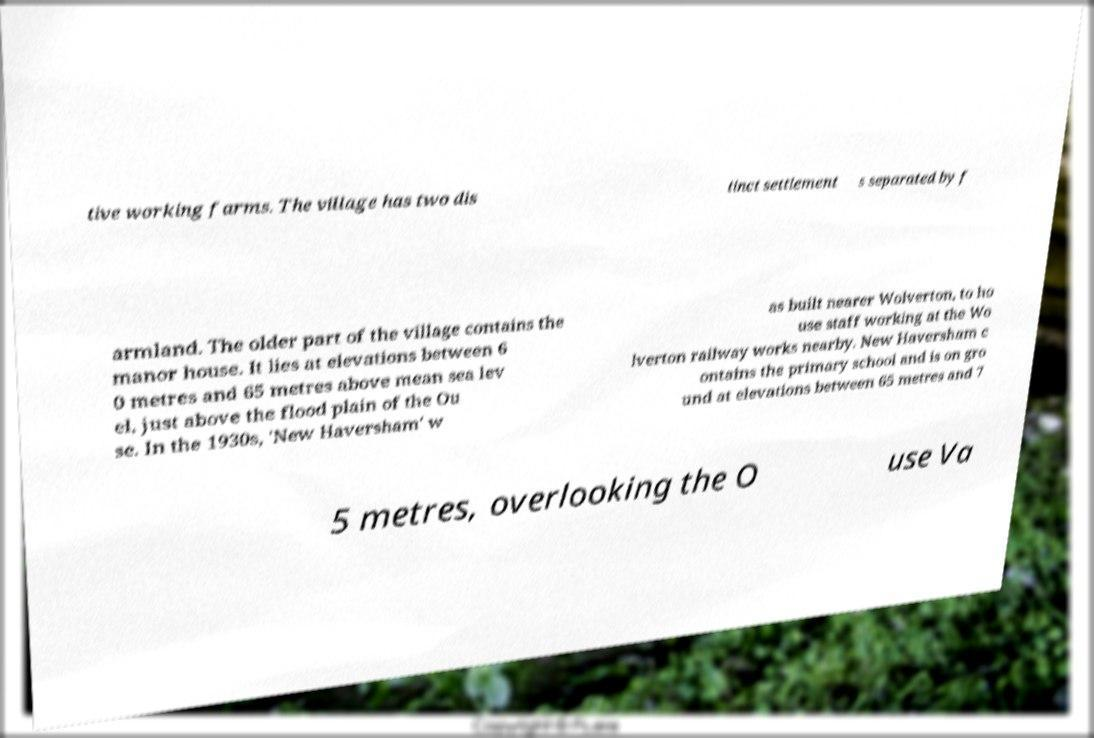What messages or text are displayed in this image? I need them in a readable, typed format. tive working farms. The village has two dis tinct settlement s separated by f armland. The older part of the village contains the manor house. It lies at elevations between 6 0 metres and 65 metres above mean sea lev el, just above the flood plain of the Ou se. In the 1930s, 'New Haversham' w as built nearer Wolverton, to ho use staff working at the Wo lverton railway works nearby. New Haversham c ontains the primary school and is on gro und at elevations between 65 metres and 7 5 metres, overlooking the O use Va 